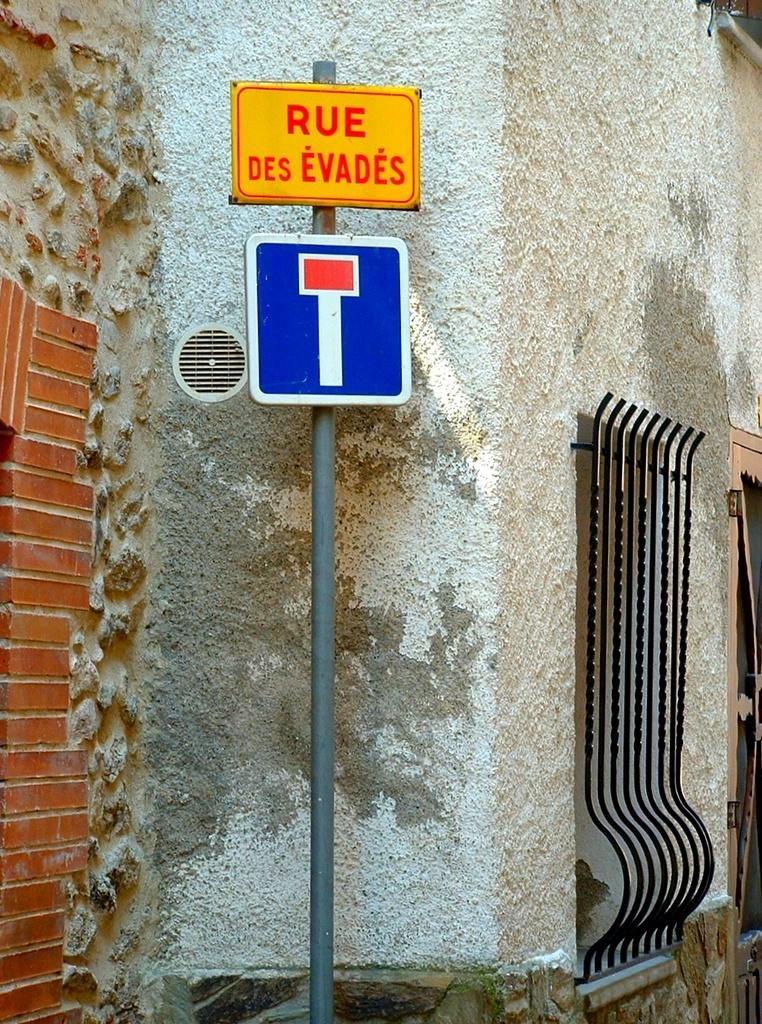<image>
Give a short and clear explanation of the subsequent image. a sign that has the word rue at the top 